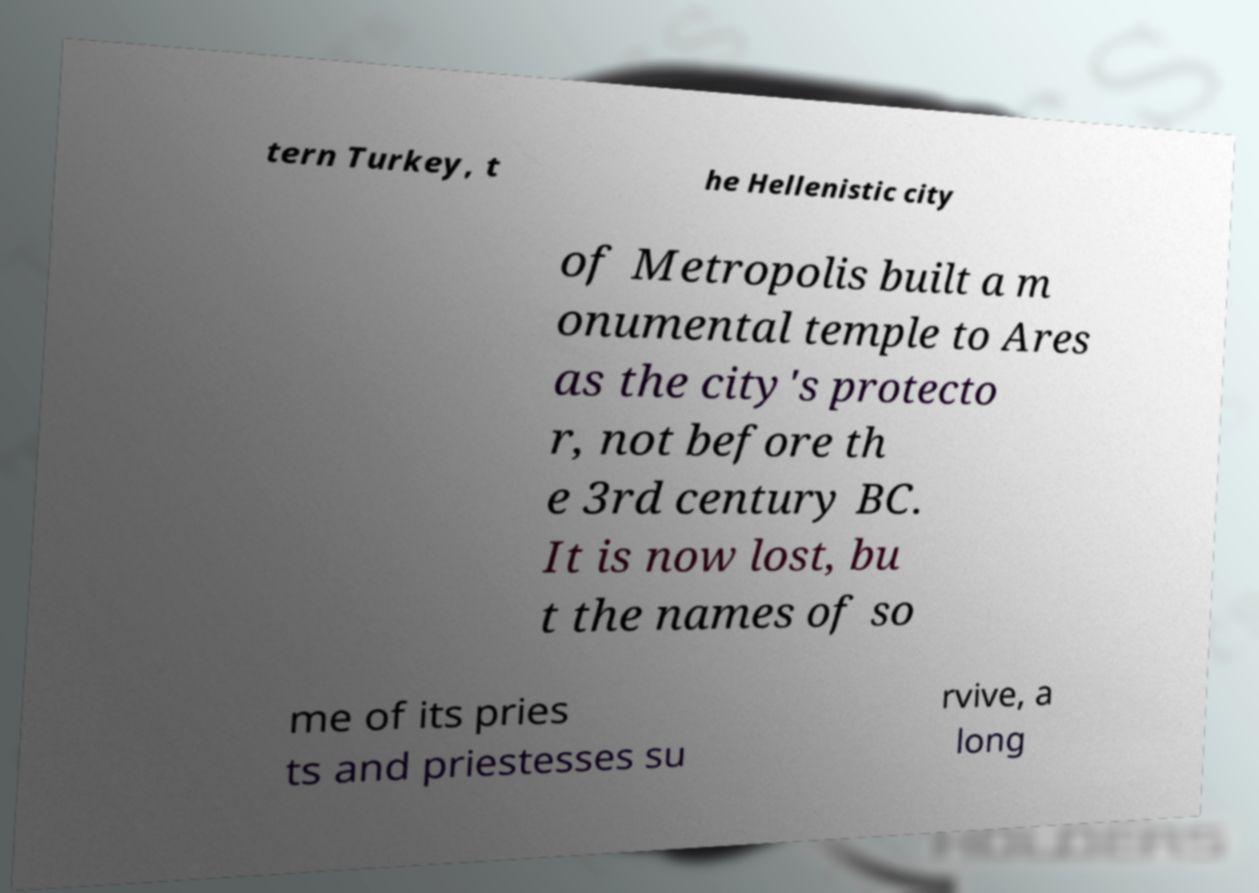Can you read and provide the text displayed in the image?This photo seems to have some interesting text. Can you extract and type it out for me? tern Turkey, t he Hellenistic city of Metropolis built a m onumental temple to Ares as the city's protecto r, not before th e 3rd century BC. It is now lost, bu t the names of so me of its pries ts and priestesses su rvive, a long 